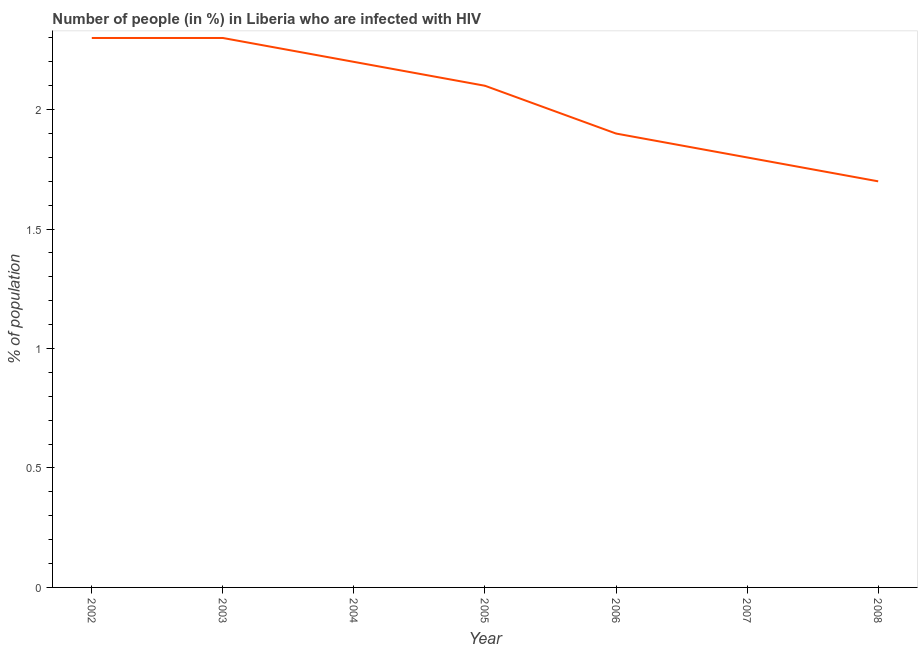What is the number of people infected with hiv in 2005?
Your response must be concise. 2.1. Across all years, what is the maximum number of people infected with hiv?
Make the answer very short. 2.3. Across all years, what is the minimum number of people infected with hiv?
Make the answer very short. 1.7. In which year was the number of people infected with hiv minimum?
Offer a terse response. 2008. What is the difference between the number of people infected with hiv in 2005 and 2006?
Offer a very short reply. 0.2. What is the average number of people infected with hiv per year?
Keep it short and to the point. 2.04. In how many years, is the number of people infected with hiv greater than 0.1 %?
Offer a very short reply. 7. What is the ratio of the number of people infected with hiv in 2002 to that in 2006?
Offer a terse response. 1.21. Is the sum of the number of people infected with hiv in 2003 and 2006 greater than the maximum number of people infected with hiv across all years?
Your answer should be compact. Yes. What is the difference between the highest and the lowest number of people infected with hiv?
Your answer should be very brief. 0.6. How many years are there in the graph?
Your response must be concise. 7. Are the values on the major ticks of Y-axis written in scientific E-notation?
Provide a succinct answer. No. Does the graph contain any zero values?
Offer a terse response. No. Does the graph contain grids?
Your answer should be very brief. No. What is the title of the graph?
Your answer should be compact. Number of people (in %) in Liberia who are infected with HIV. What is the label or title of the X-axis?
Offer a terse response. Year. What is the label or title of the Y-axis?
Offer a very short reply. % of population. What is the % of population of 2002?
Your response must be concise. 2.3. What is the % of population in 2005?
Your response must be concise. 2.1. What is the % of population of 2006?
Your response must be concise. 1.9. What is the % of population in 2007?
Provide a succinct answer. 1.8. What is the difference between the % of population in 2002 and 2005?
Give a very brief answer. 0.2. What is the difference between the % of population in 2002 and 2007?
Provide a succinct answer. 0.5. What is the difference between the % of population in 2002 and 2008?
Make the answer very short. 0.6. What is the difference between the % of population in 2003 and 2005?
Provide a succinct answer. 0.2. What is the difference between the % of population in 2003 and 2007?
Keep it short and to the point. 0.5. What is the difference between the % of population in 2004 and 2005?
Provide a succinct answer. 0.1. What is the difference between the % of population in 2004 and 2007?
Provide a succinct answer. 0.4. What is the difference between the % of population in 2005 and 2006?
Provide a short and direct response. 0.2. What is the difference between the % of population in 2005 and 2008?
Ensure brevity in your answer.  0.4. What is the difference between the % of population in 2006 and 2007?
Your answer should be very brief. 0.1. What is the difference between the % of population in 2006 and 2008?
Keep it short and to the point. 0.2. What is the ratio of the % of population in 2002 to that in 2004?
Your response must be concise. 1.04. What is the ratio of the % of population in 2002 to that in 2005?
Your response must be concise. 1.09. What is the ratio of the % of population in 2002 to that in 2006?
Ensure brevity in your answer.  1.21. What is the ratio of the % of population in 2002 to that in 2007?
Ensure brevity in your answer.  1.28. What is the ratio of the % of population in 2002 to that in 2008?
Provide a succinct answer. 1.35. What is the ratio of the % of population in 2003 to that in 2004?
Your answer should be compact. 1.04. What is the ratio of the % of population in 2003 to that in 2005?
Your answer should be very brief. 1.09. What is the ratio of the % of population in 2003 to that in 2006?
Your answer should be compact. 1.21. What is the ratio of the % of population in 2003 to that in 2007?
Your answer should be very brief. 1.28. What is the ratio of the % of population in 2003 to that in 2008?
Make the answer very short. 1.35. What is the ratio of the % of population in 2004 to that in 2005?
Provide a short and direct response. 1.05. What is the ratio of the % of population in 2004 to that in 2006?
Ensure brevity in your answer.  1.16. What is the ratio of the % of population in 2004 to that in 2007?
Your response must be concise. 1.22. What is the ratio of the % of population in 2004 to that in 2008?
Ensure brevity in your answer.  1.29. What is the ratio of the % of population in 2005 to that in 2006?
Provide a succinct answer. 1.1. What is the ratio of the % of population in 2005 to that in 2007?
Your answer should be very brief. 1.17. What is the ratio of the % of population in 2005 to that in 2008?
Your answer should be compact. 1.24. What is the ratio of the % of population in 2006 to that in 2007?
Ensure brevity in your answer.  1.06. What is the ratio of the % of population in 2006 to that in 2008?
Provide a short and direct response. 1.12. What is the ratio of the % of population in 2007 to that in 2008?
Ensure brevity in your answer.  1.06. 